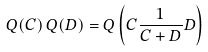<formula> <loc_0><loc_0><loc_500><loc_500>Q ( C ) \, Q ( D ) = Q \left ( C \frac { 1 } { C + D } D \right )</formula> 